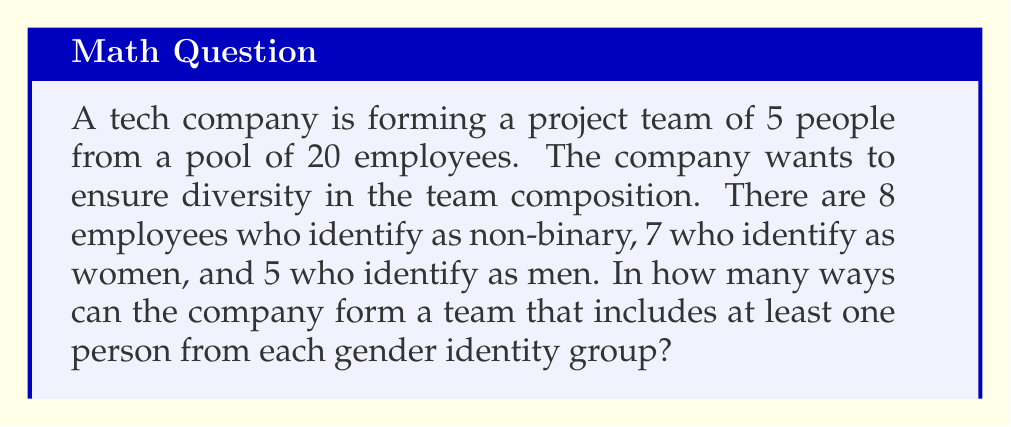Show me your answer to this math problem. Let's approach this step-by-step using the inclusion-exclusion principle:

1) First, let's calculate the total number of ways to choose 5 people from 20:
   $$\binom{20}{5}$$

2) Now, we need to subtract the number of ways that exclude at least one group:

   a) Teams without non-binary individuals: $\binom{12}{5}$
   b) Teams without women: $\binom{13}{5}$
   c) Teams without men: $\binom{15}{5}$

3) However, this subtraction counts some teams twice, so we need to add back:

   d) Teams without non-binary individuals or women: $\binom{5}{5}$
   e) Teams without non-binary individuals or men: $\binom{7}{5}$
   f) Teams without women or men: $\binom{8}{5}$

4) Finally, we've counted teams with no diversity (all from one group) an extra time, so subtract:

   g) Teams with only men: $\binom{5}{5}$
   h) Teams with only women: $\binom{7}{5}$
   i) Teams with only non-binary individuals: $\binom{8}{5}$

5) Putting it all together:

   $$\binom{20}{5} - \left(\binom{12}{5} + \binom{13}{5} + \binom{15}{5}\right) + \left(\binom{5}{5} + \binom{7}{5} + \binom{8}{5}\right) - \left(\binom{5}{5} + \binom{7}{5} + \binom{8}{5}\right)$$

6) Calculating:
   $$15504 - (792 + 1287 + 3003) + (1 + 21 + 56) - (1 + 0 + 1) = 10498$$
Answer: 10498 